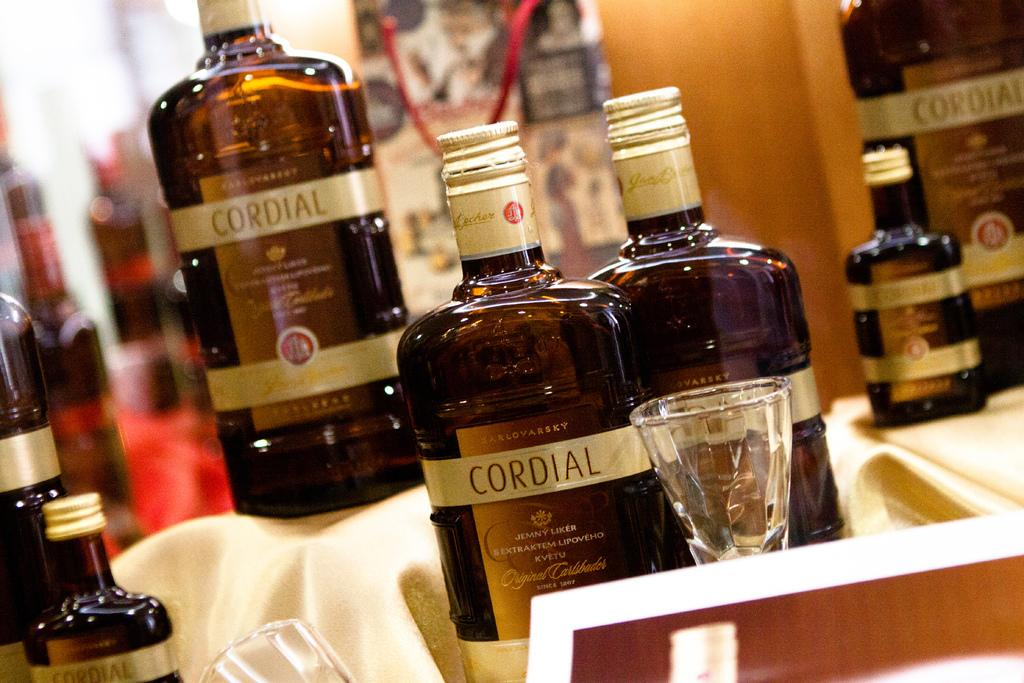<image>
Share a concise interpretation of the image provided. A series of Cordial full bottles with an empty shot glass. 